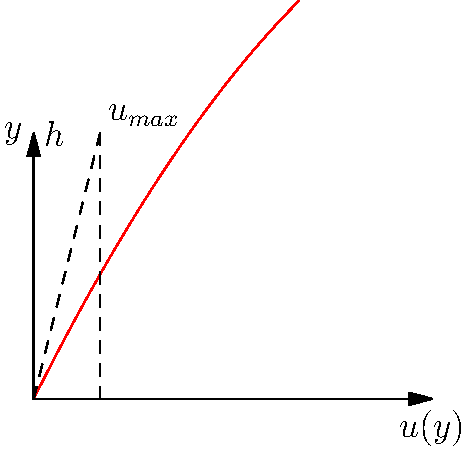In a fluid dynamics experiment, you're studying the flow between two parallel plates separated by a distance $h$. The velocity profile is given by the equation $u(y) = \frac{4y}{h} - \frac{y^2}{h^2}$, where $y$ is the distance from the lower plate. What is the maximum velocity $u_{max}$ and at what position $y$ does it occur? To find the maximum velocity and its position, we need to follow these steps:

1) The maximum velocity occurs where the derivative of $u(y)$ with respect to $y$ is zero. Let's find $\frac{du}{dy}$:

   $\frac{du}{dy} = \frac{4}{h} - \frac{2y}{h^2}$

2) Set this equal to zero and solve for $y$:

   $\frac{4}{h} - \frac{2y}{h^2} = 0$
   $\frac{4}{h} = \frac{2y}{h^2}$
   $4h = 2y$
   $y = \frac{h}{2}$

3) The maximum velocity occurs at $y = \frac{h}{2}$, which is halfway between the plates.

4) To find $u_{max}$, substitute $y = \frac{h}{2}$ into the original equation:

   $u_{max} = u(\frac{h}{2}) = \frac{4(\frac{h}{2})}{h} - \frac{(\frac{h}{2})^2}{h^2}$
   
   $= \frac{4h}{2h} - \frac{h^2}{4h^2} = 2 - \frac{1}{4} = \frac{7}{4} = 1.75$

5) Therefore, the maximum velocity is $u_{max} = \frac{7}{4}$ or 1.75 (in units of velocity), occurring at $y = \frac{h}{2}$.
Answer: $u_{max} = \frac{7}{4}$ at $y = \frac{h}{2}$ 